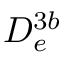Convert formula to latex. <formula><loc_0><loc_0><loc_500><loc_500>D _ { e } ^ { 3 b }</formula> 